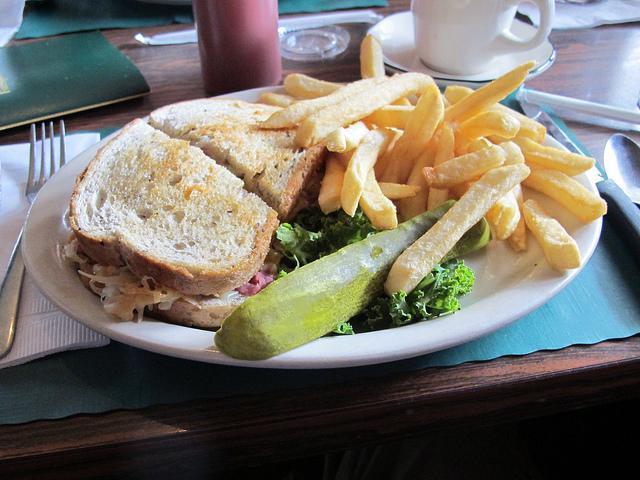How many pieces of silverware are there?
Give a very brief answer. 3. How many pieces is the sandwich cut into?
Give a very brief answer. 2. How many sandwiches are in the photo?
Give a very brief answer. 2. 